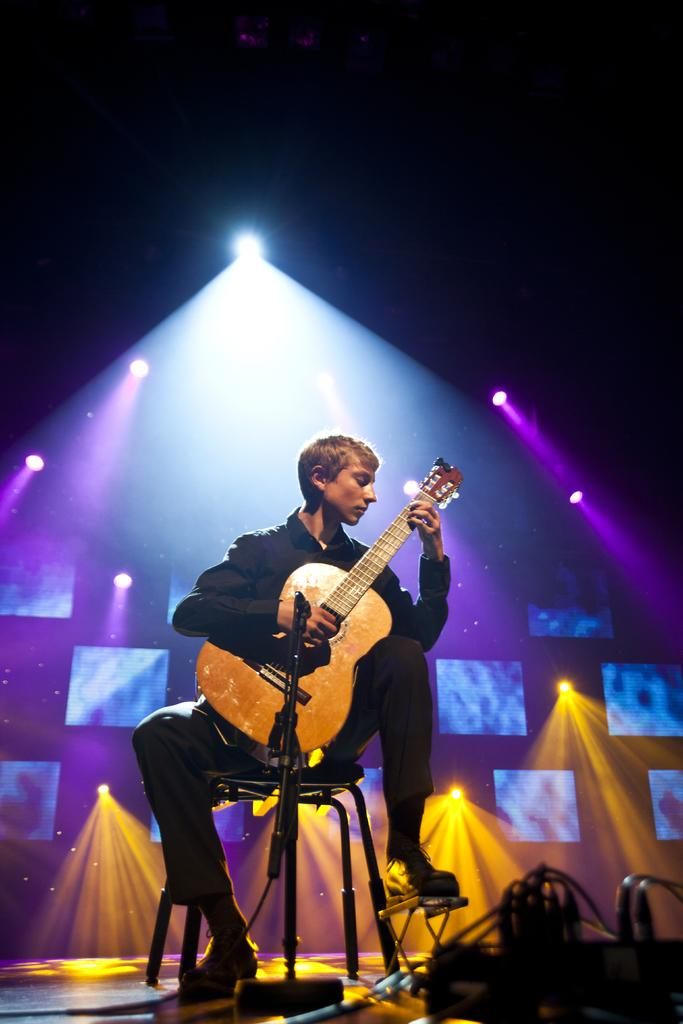What can be seen in the image that provides illumination? There are lights in the image. What can be seen in the background of the image? There are posts visible in the background. What is the person in the image doing? The person is sitting on a chair and playing a guitar. What object is the person in front of? The person is in front of a microphone. What type of eggnog is being served at the concert in the image? There is no eggnog present in the image, nor is there a concert taking place. What rhythm is the person playing on the guitar in the image? The image does not provide information about the rhythm being played on the guitar. 